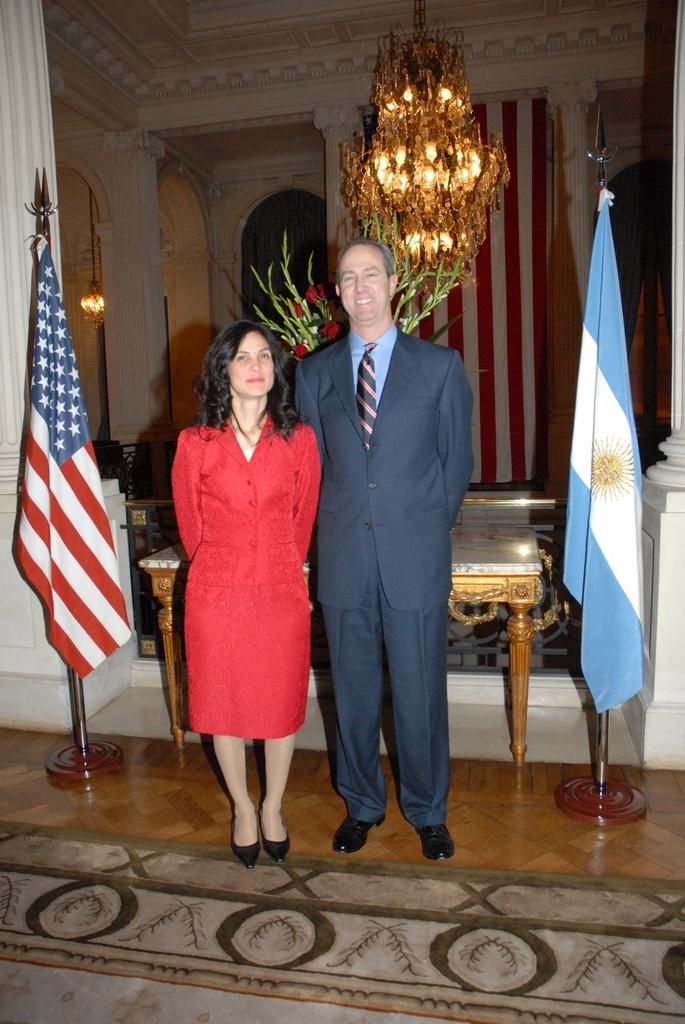How many people are present in the image? There are two persons standing in the image. What else can be seen in the image besides the people? There are two flags and a table in the image. Is there any lighting fixture visible in the image? Yes, there is a chandelier visible at the top of the image. What type of wrist accessory is visible on the person on the left in the image? There is no wrist accessory visible on the person on the left in the image. 